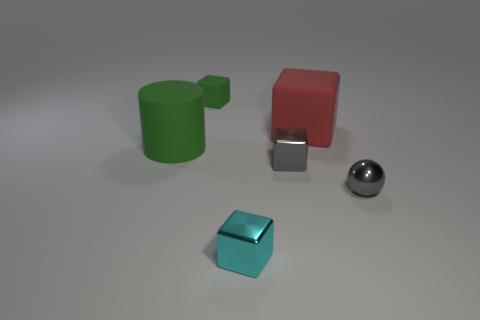How many purple things are rubber objects or tiny rubber things?
Give a very brief answer. 0. The tiny cyan object is what shape?
Your response must be concise. Cube. What number of other things are the same shape as the large green thing?
Your answer should be compact. 0. What is the color of the big object that is behind the big cylinder?
Provide a short and direct response. Red. Are the big cylinder and the red thing made of the same material?
Offer a terse response. Yes. How many things are red matte objects or small shiny objects on the left side of the red block?
Offer a very short reply. 3. There is a matte cylinder that is the same color as the tiny rubber thing; what is its size?
Offer a terse response. Large. There is a large object on the left side of the tiny gray cube; what is its shape?
Provide a short and direct response. Cylinder. There is a rubber thing behind the red cube; is it the same color as the big cylinder?
Your answer should be compact. Yes. There is a large cylinder that is the same color as the tiny rubber thing; what is its material?
Your answer should be compact. Rubber. 